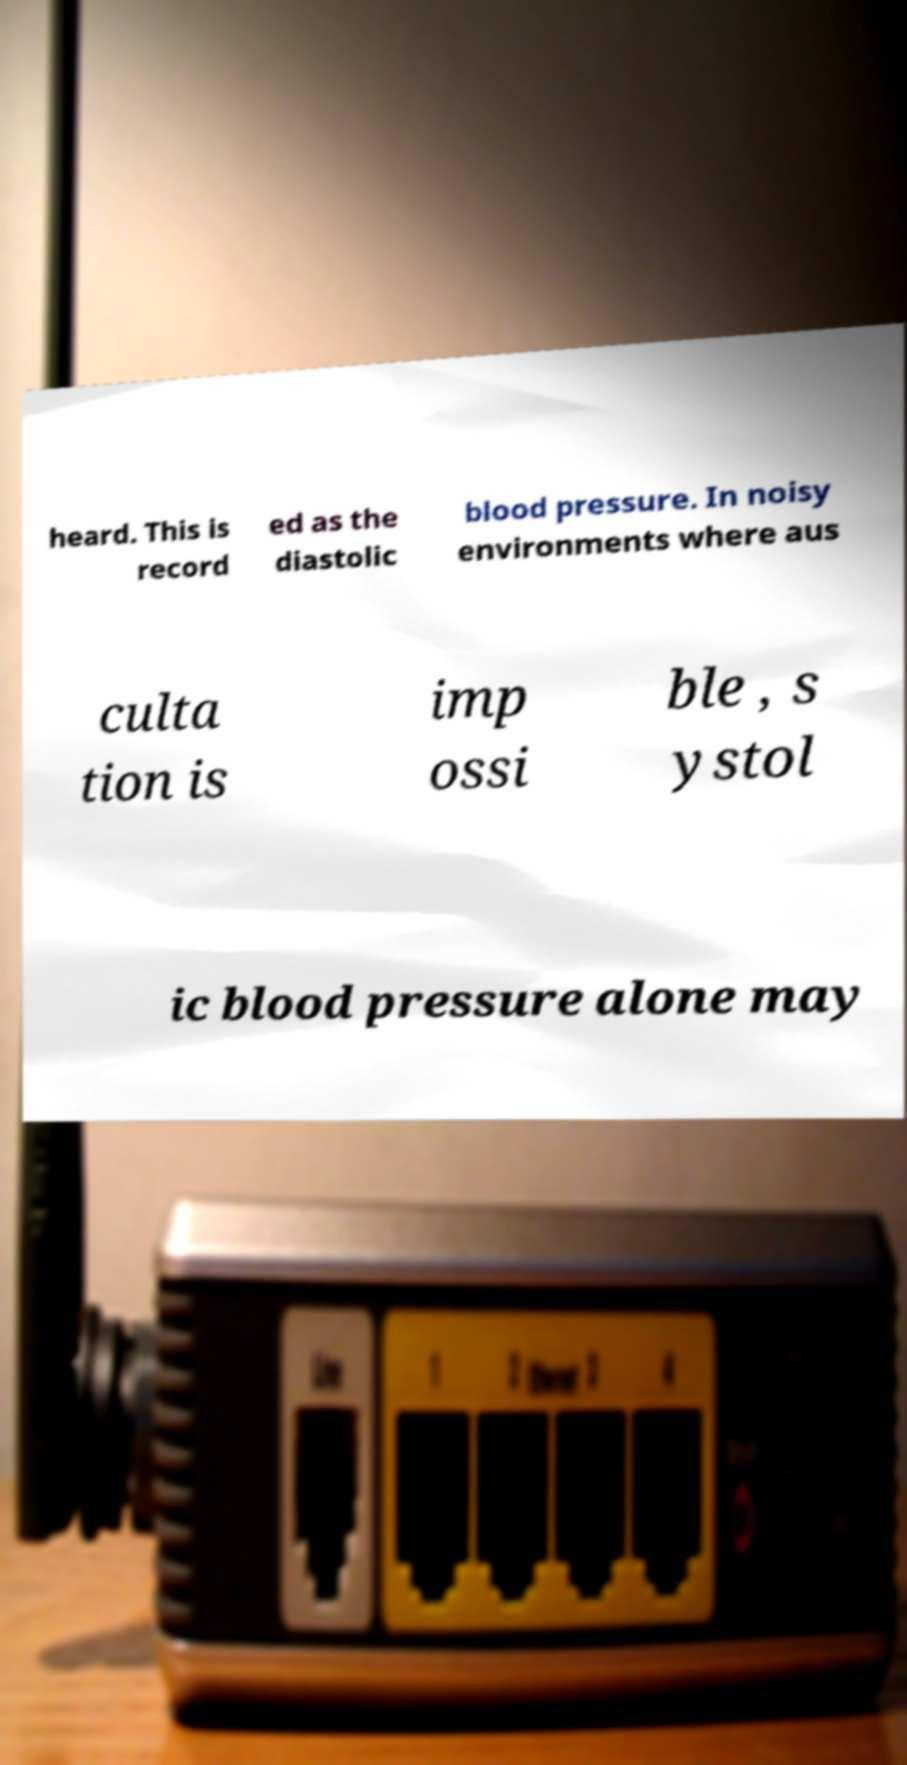What messages or text are displayed in this image? I need them in a readable, typed format. heard. This is record ed as the diastolic blood pressure. In noisy environments where aus culta tion is imp ossi ble , s ystol ic blood pressure alone may 